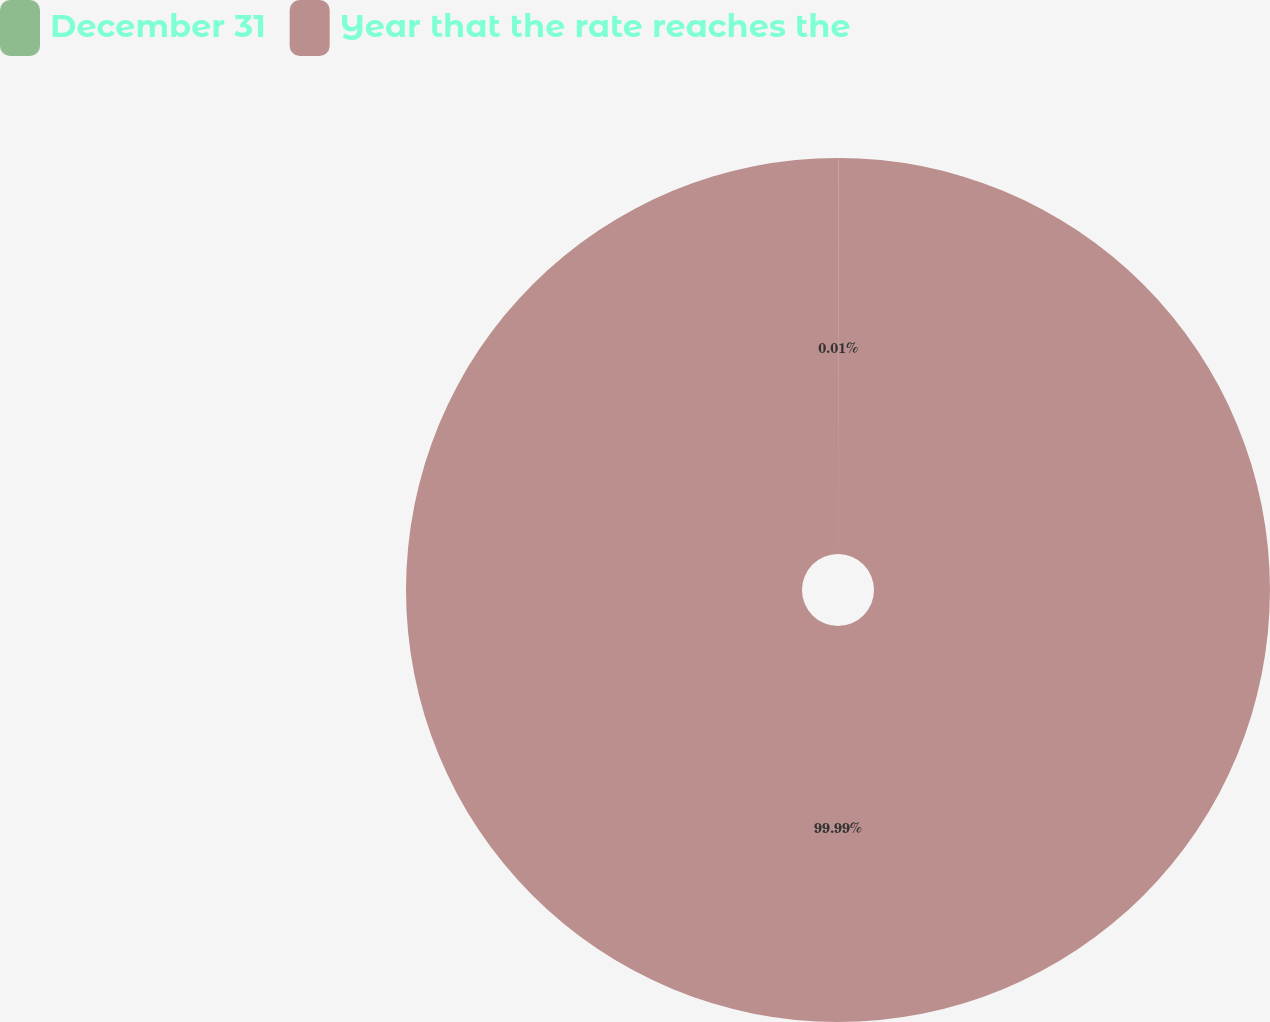Convert chart to OTSL. <chart><loc_0><loc_0><loc_500><loc_500><pie_chart><fcel>December 31<fcel>Year that the rate reaches the<nl><fcel>0.01%<fcel>99.99%<nl></chart> 